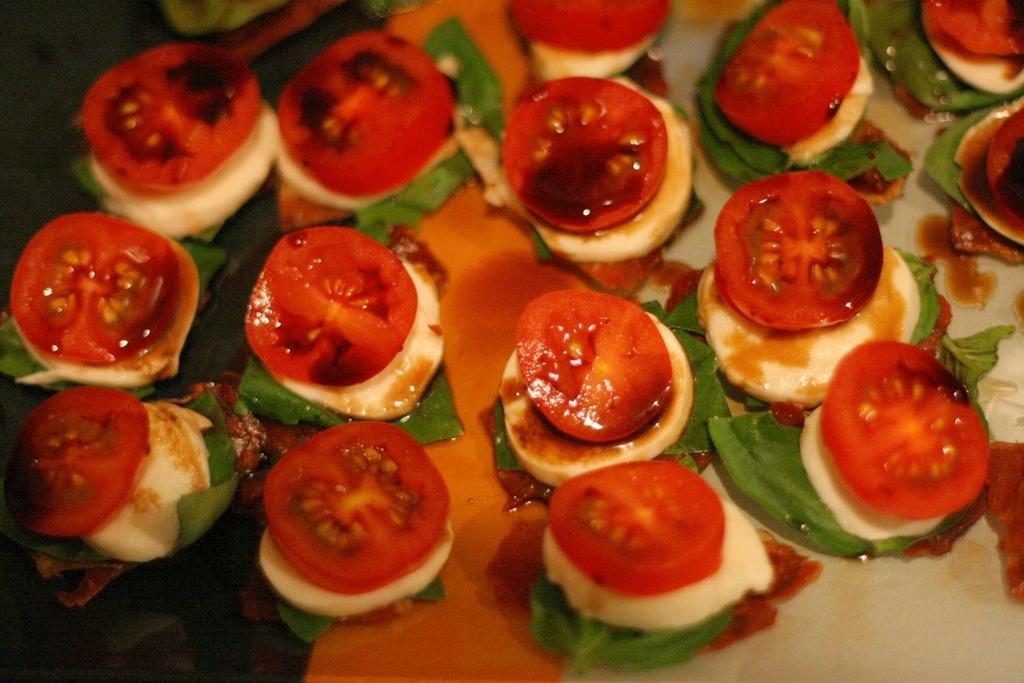Can you describe this image briefly? In the image we can see a plate, in the plate there is a food item. These are the slices of tomato and this are the leaves. 